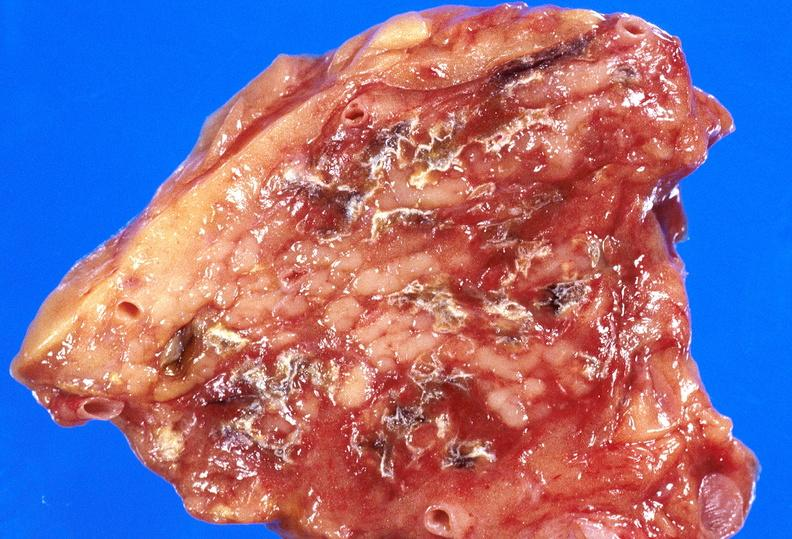what does this image show?
Answer the question using a single word or phrase. Pancreatic fat necrosis 